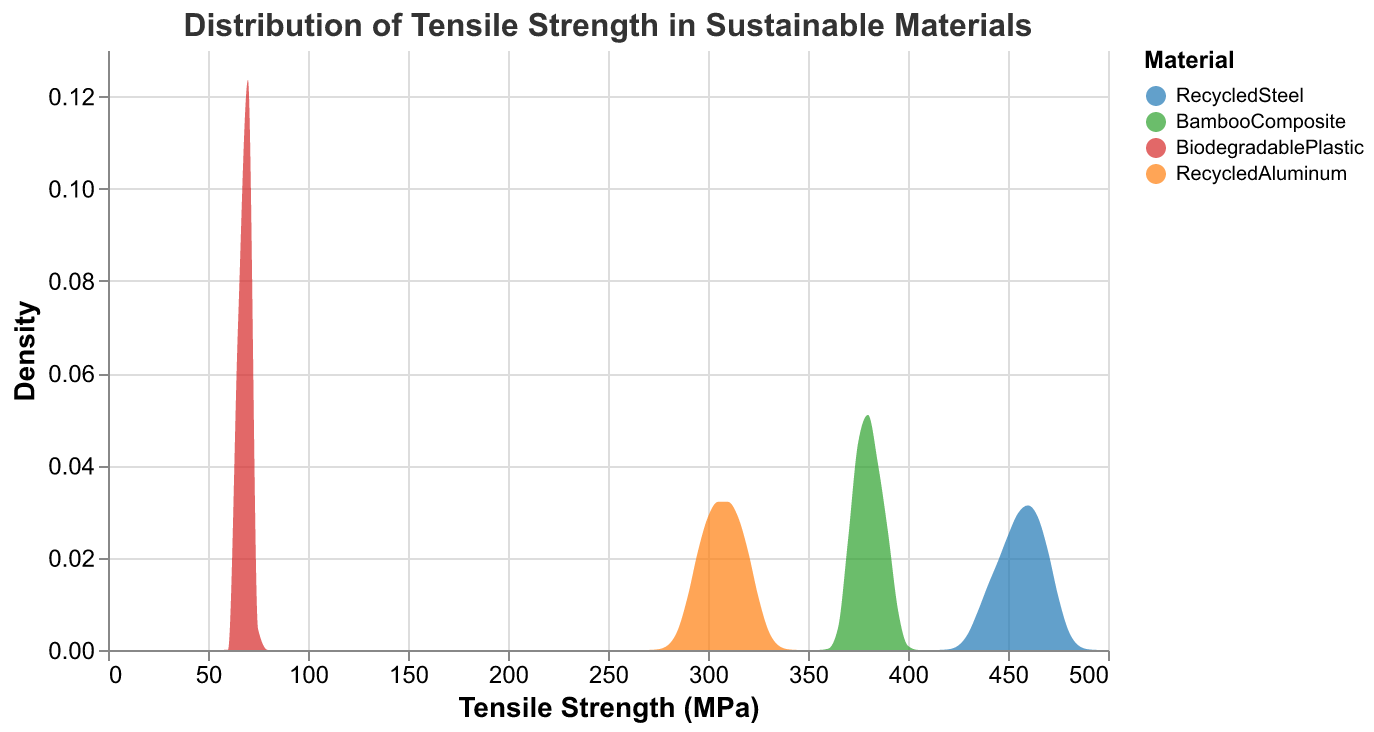What is the title of the figure? The title is located at the top of the figure and it describes what the figure represents.
Answer: Distribution of Tensile Strength in Sustainable Materials What are the four materials compared in this figure? The materials are distinguished by different colors, which are indicated in the legend on the right side of the figure.
Answer: RecycledSteel, BambooComposite, BiodegradablePlastic, RecycledAluminum Which material has the highest tensile strength? By examining the x-axis, we can observe that the distribution for the highest tensile strength belongs to one material.
Answer: RecycledSteel Which material shows the lowest range of tensile strength? The range of tensile strength for each material can be estimated by the extent of their density distribution along the x-axis. The material with the narrowest span indicates the lowest range.
Answer: BiodegradablePlastic How does the tensile strength of RecycledSteel compare to that of BambooComposite? Looking at where the distributions lie on the x-axis, RecycledSteel has tensile strengths ranging mostly in the 440-470 MPa, whereas BambooComposite ranges around 370-390 MPa.
Answer: RecycledSteel has a significantly higher tensile strength compared to BambooComposite Which material has the most consistent tensile strength based on the figure? Consistency in tensile strength can be inferred from a sharper peak in the density plot. The sharper the peak, the more consistent the values are.
Answer: BiodegradablePlastic What is the trend in tensile strength among the materials, from least to greatest? Observing the x-axis ranges for each material, we can rank them according to their tensile strength densities.
Answer: BiodegradablePlastic < RecycledAluminum < BambooComposite < RecycledSteel What is the typical tensile strength range for BiodegradablePlastic? The density plot for BiodegradablePlastic spans a specific range on the x-axis, indicating its typical tensile strength values.
Answer: 65-72 MPa Among the listed materials, which has the most varied tensile strength? A more varied tensile strength will be indicated by a broader distribution on the x-axis.
Answer: RecycledSteel 